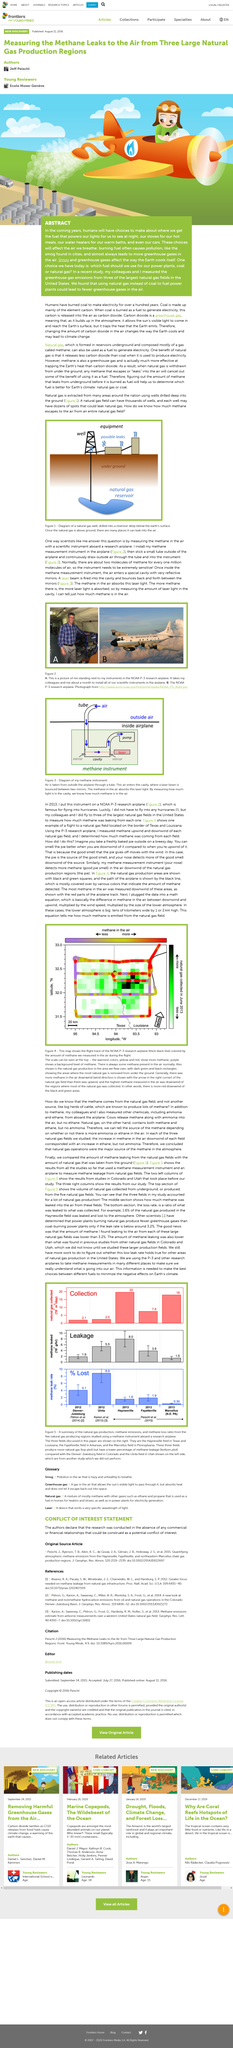Indicate a few pertinent items in this graphic. The use of natural gas instead of coal in power plants would result in fewer greenhouse gases in the air. The way in which the Earth cools itself is influenced by both smog and greenhouse gases. In the coming years, our fuel choices will have a significant impact on the air we breathe. These choices will ultimately determine the health of our planet and the well-being of future generations. 